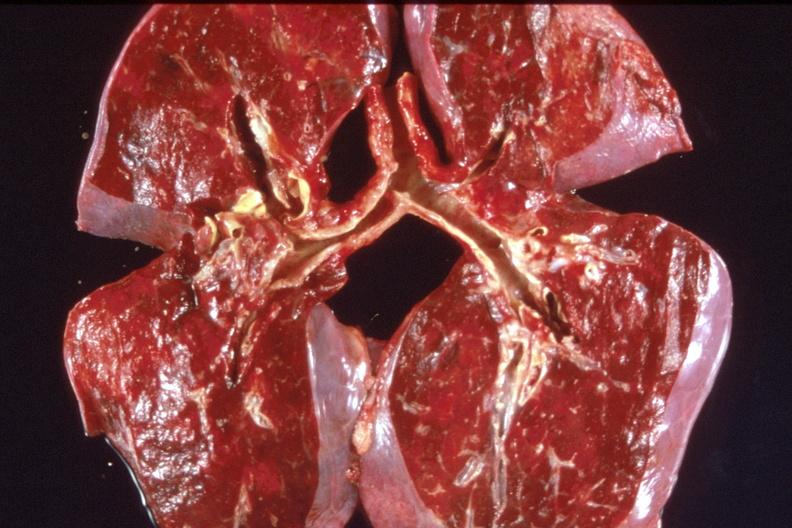does this image show lung, pulmonary fibrosis and congestion?
Answer the question using a single word or phrase. Yes 